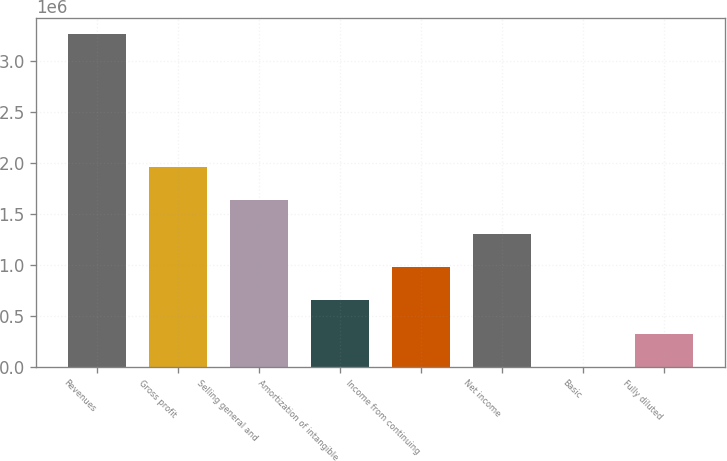Convert chart to OTSL. <chart><loc_0><loc_0><loc_500><loc_500><bar_chart><fcel>Revenues<fcel>Gross profit<fcel>Selling general and<fcel>Amortization of intangible<fcel>Income from continuing<fcel>Net income<fcel>Basic<fcel>Fully diluted<nl><fcel>3.26238e+06<fcel>1.95743e+06<fcel>1.63119e+06<fcel>652477<fcel>978715<fcel>1.30495e+06<fcel>0.68<fcel>326239<nl></chart> 